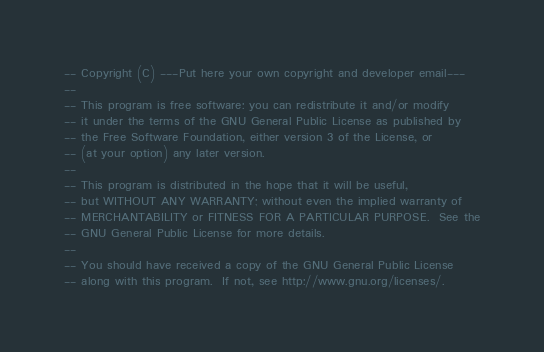Convert code to text. <code><loc_0><loc_0><loc_500><loc_500><_SQL_>-- Copyright (C) ---Put here your own copyright and developer email---
--
-- This program is free software: you can redistribute it and/or modify
-- it under the terms of the GNU General Public License as published by
-- the Free Software Foundation, either version 3 of the License, or
-- (at your option) any later version.
--
-- This program is distributed in the hope that it will be useful,
-- but WITHOUT ANY WARRANTY; without even the implied warranty of
-- MERCHANTABILITY or FITNESS FOR A PARTICULAR PURPOSE.  See the
-- GNU General Public License for more details.
--
-- You should have received a copy of the GNU General Public License
-- along with this program.  If not, see http://www.gnu.org/licenses/.
</code> 